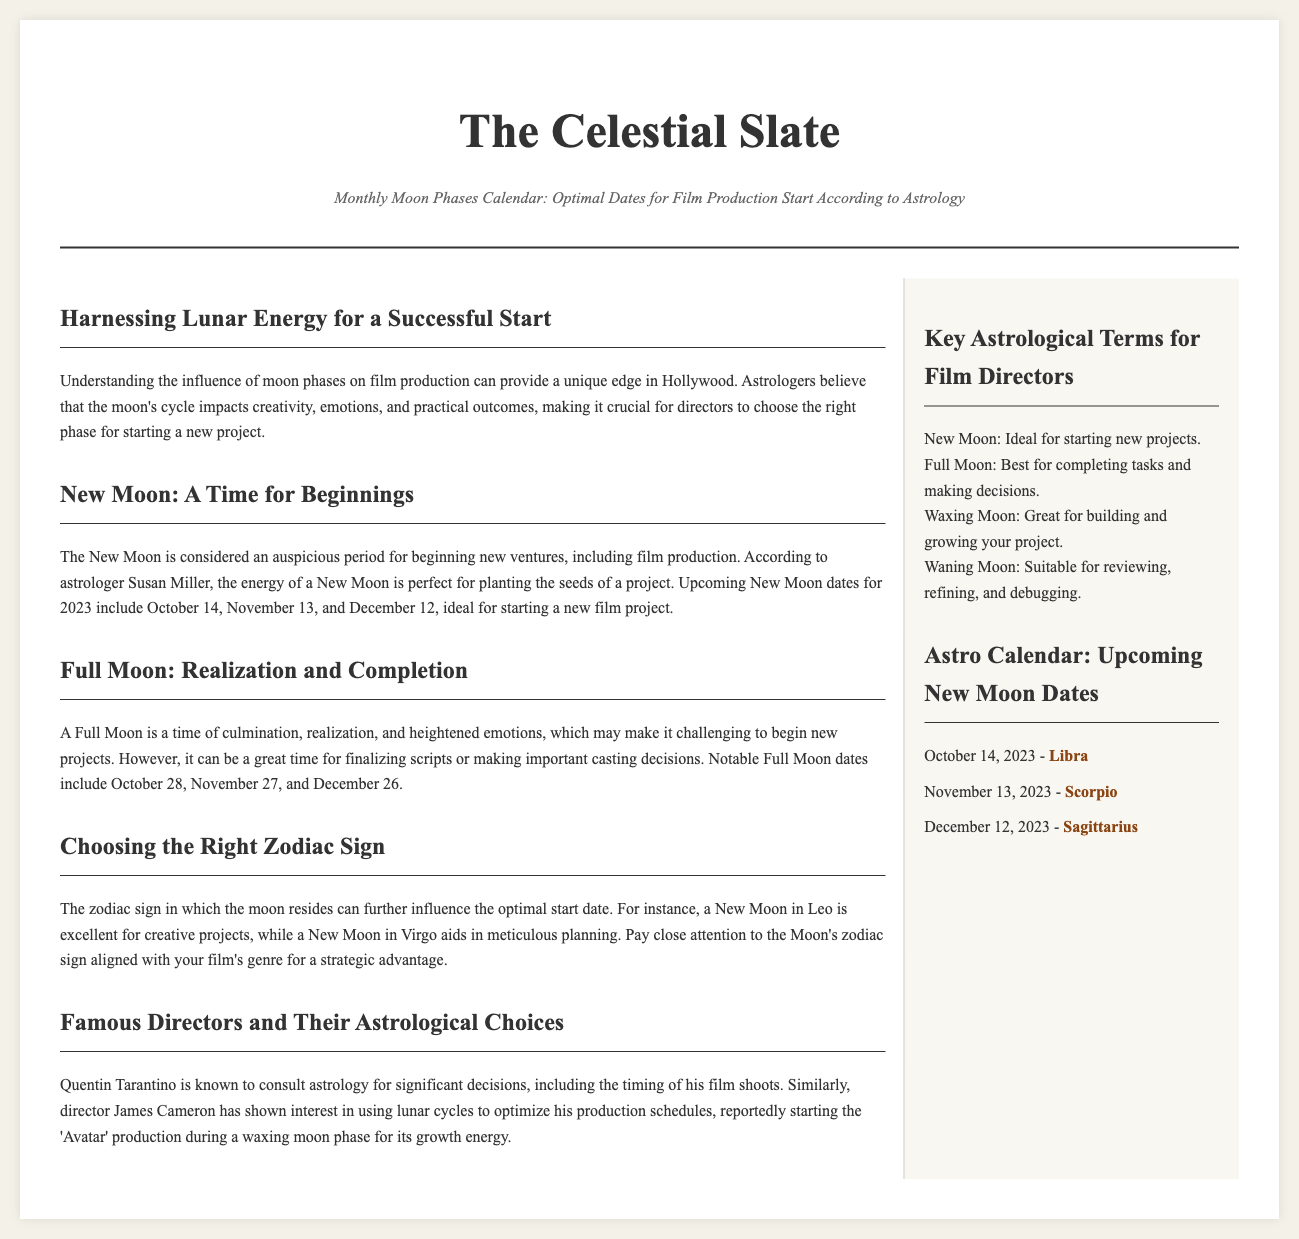what is the title of the document? The title is prominently displayed at the top of the document, indicating the main focus of the content.
Answer: The Celestial Slate what is the subtitle of the document? The subtitle explains the purpose of the content and provides context about the topic being discussed.
Answer: Monthly Moon Phases Calendar: Optimal Dates for Film Production Start According to Astrology how many New Moon dates are listed for 2023? The document provides a specific number of New Moon dates within the main articles, indicating their relevance for film production.
Answer: 3 which zodiac sign corresponds to the New Moon on October 14, 2023? The zodiac sign attributed to this New Moon date is mentioned in the sidebar, providing additional astrological context.
Answer: Libra what is the purpose of a Full Moon according to the document? The article discusses the significance and purpose of the Full Moon phase in relation to film production tasks.
Answer: Finalizing scripts or making important casting decisions what is a beneficial time period for starting new projects? The document describes astrological beliefs regarding timing for starting ventures, highlighting specific lunar phases.
Answer: New Moon which famous director consults astrology for decision-making? The article mentions a well-known director who utilizes astrology in his filmmaking process, reflecting industry practices.
Answer: Quentin Tarantino how does the document categorize the Waxing Moon? The sidebar provides definitions of different moon phases, explaining their suitability for project development.
Answer: Great for building and growing your project what is highlighted as a strategic advantage when starting a film project? The document highlights astrological elements that can influence project initiation, suggesting a tactical approach for directors.
Answer: Choosing the Right Zodiac Sign 